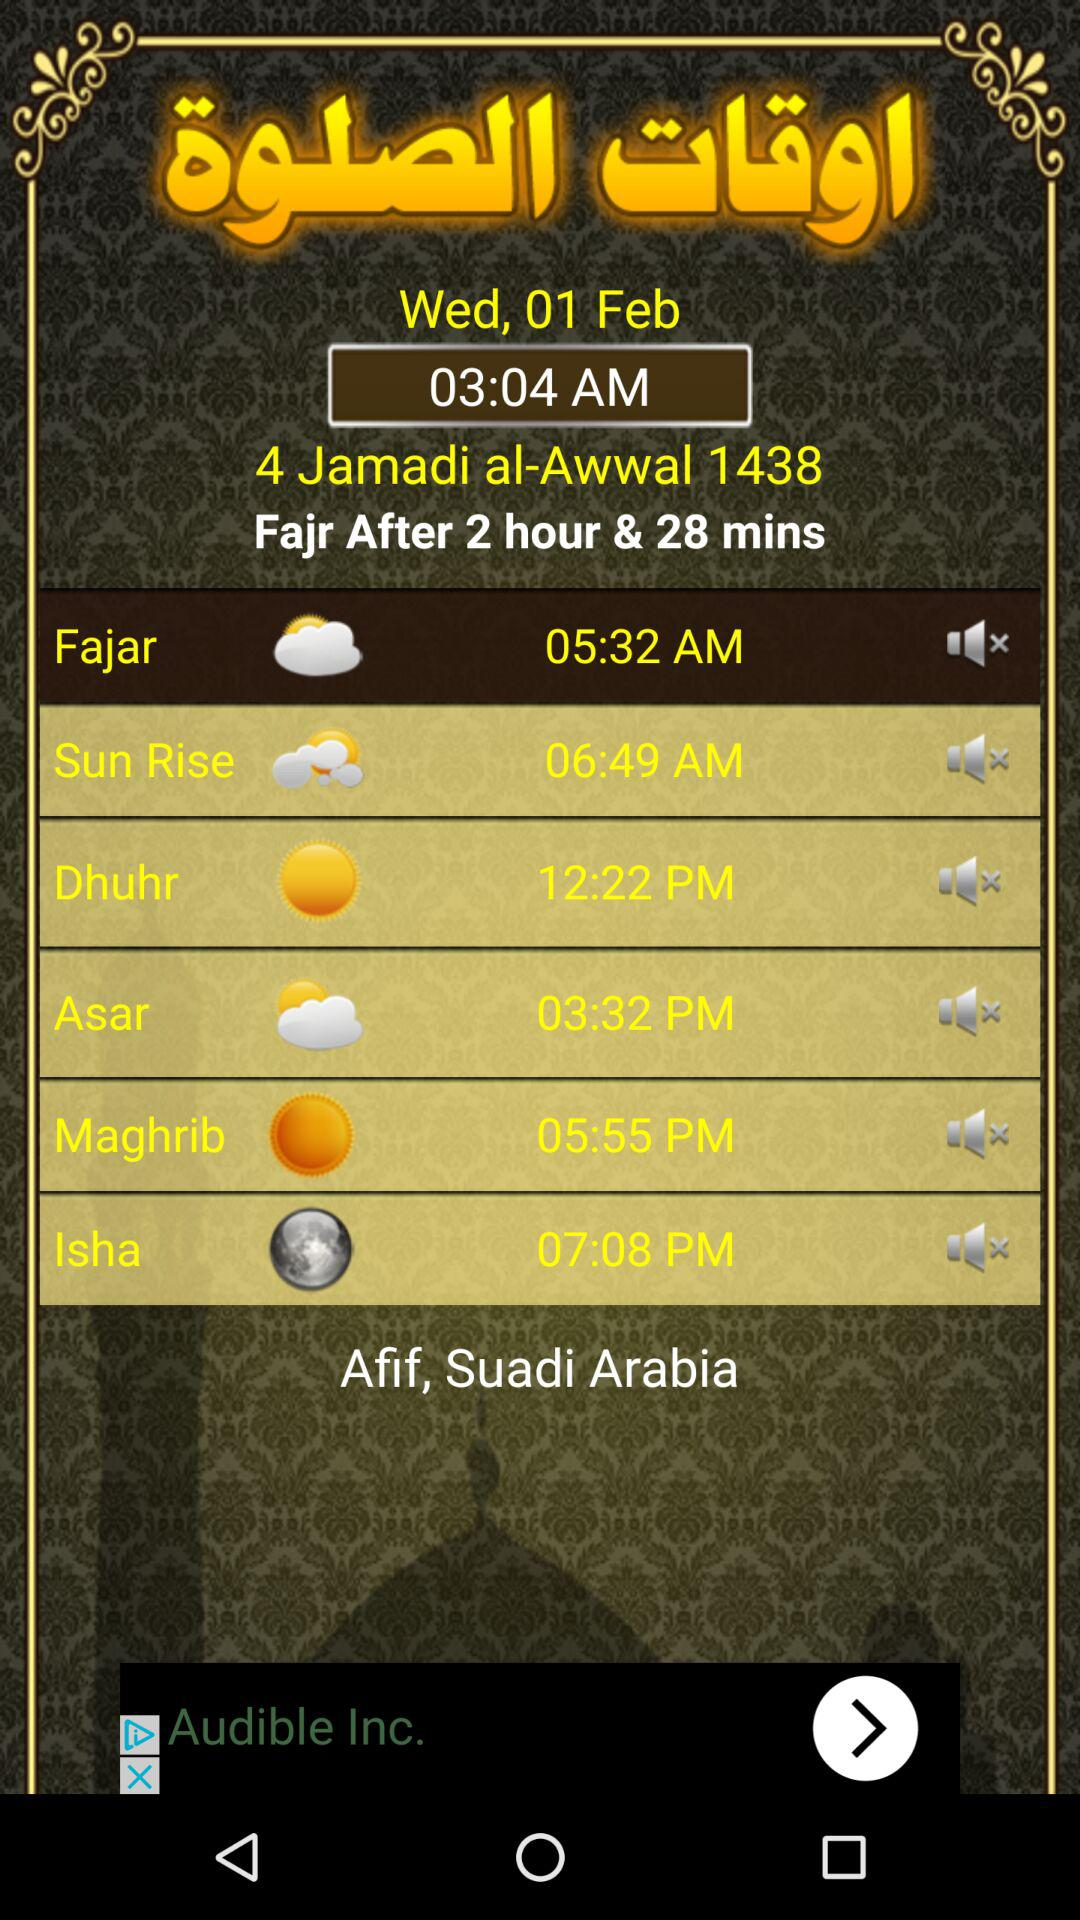What is the time of "Sun Rise"? The time of "Sun Rise" is 6:49 a.m. 